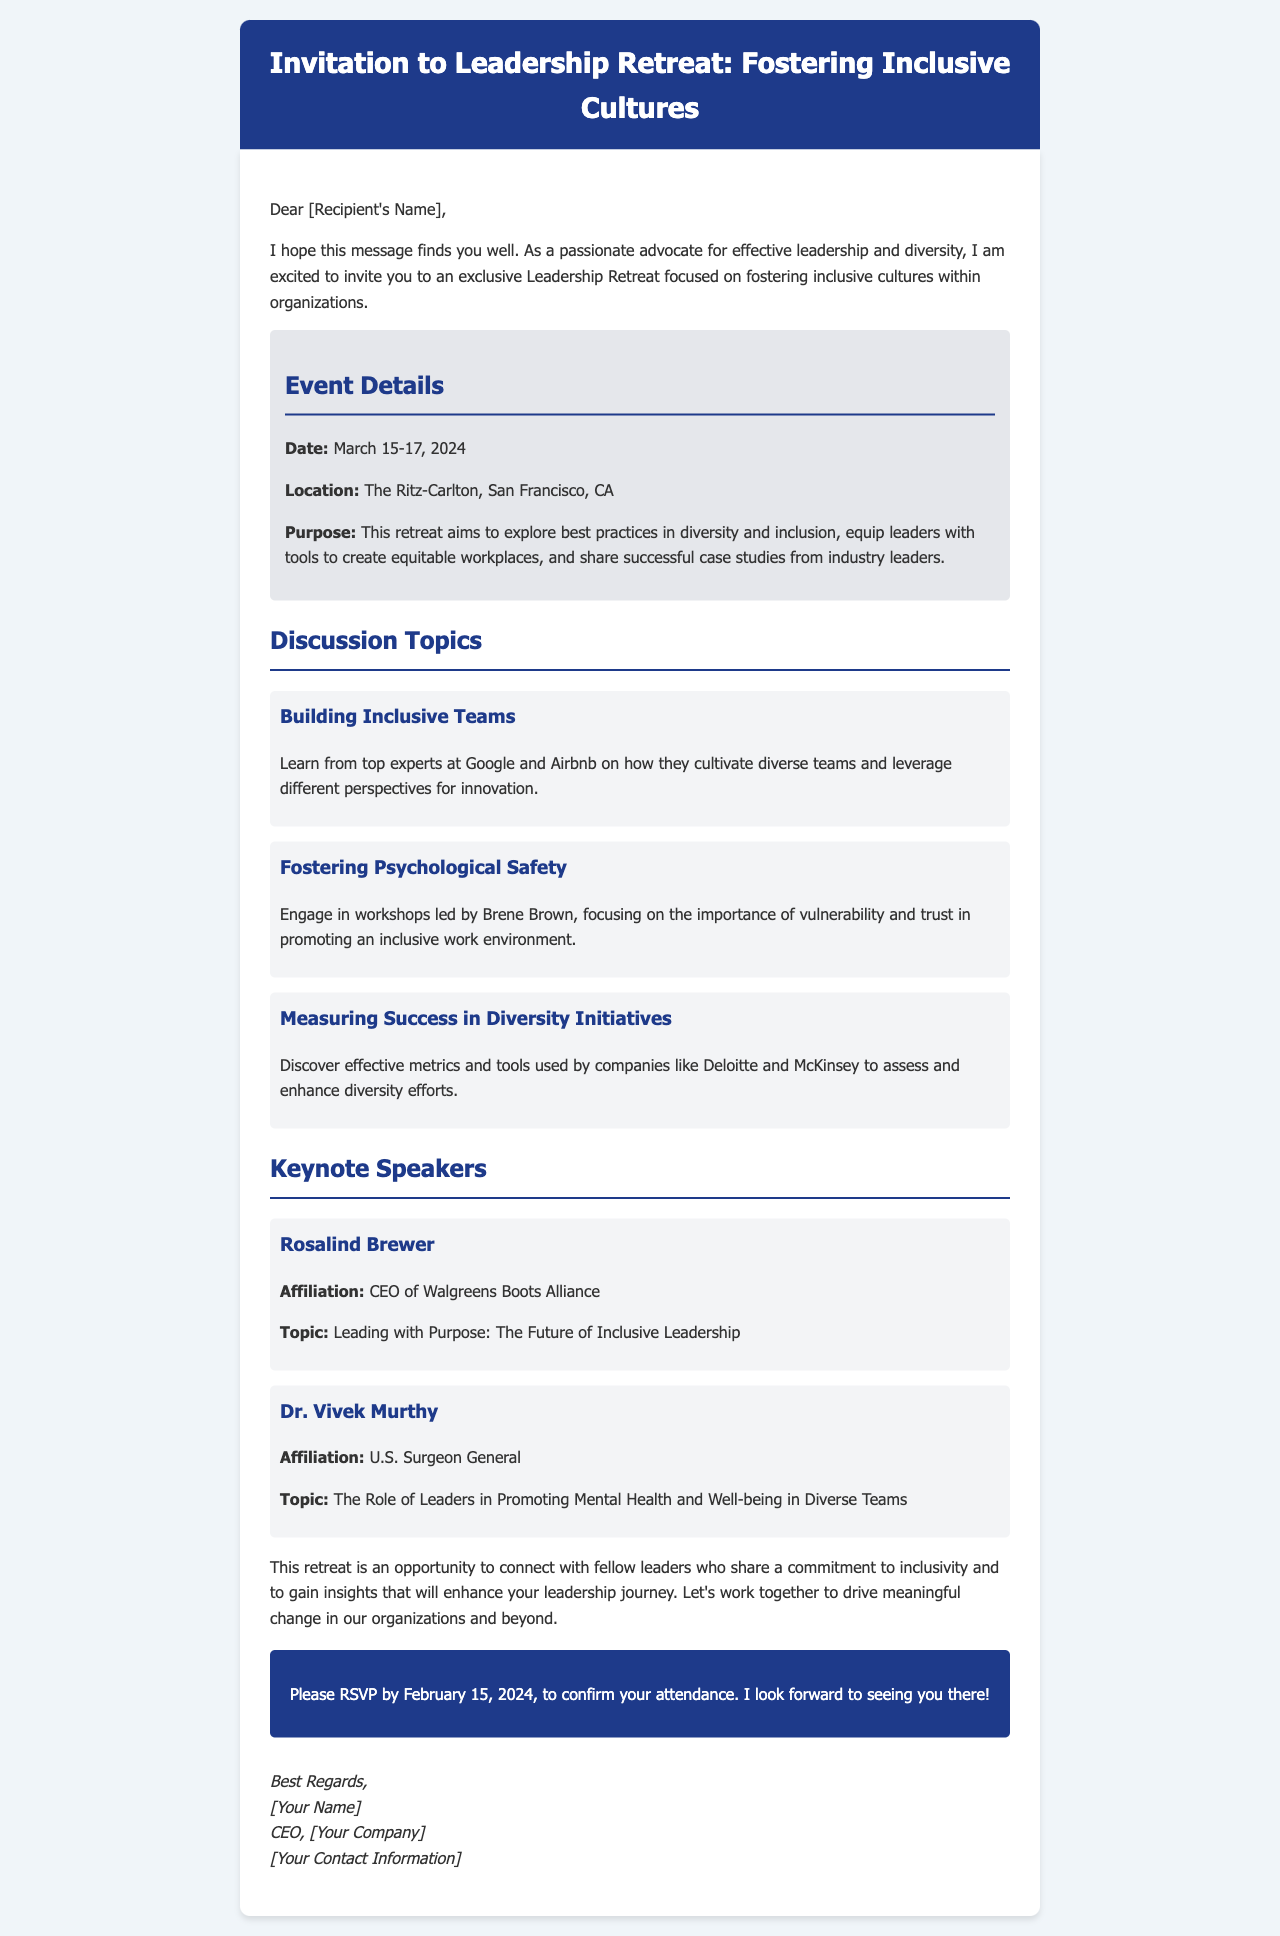What are the dates of the retreat? The document clearly states the dates for the retreat which are March 15-17, 2024.
Answer: March 15-17, 2024 Where is the retreat taking place? The document mentions that the location of the retreat is The Ritz-Carlton, San Francisco, CA.
Answer: The Ritz-Carlton, San Francisco, CA What is the purpose of the retreat? The purpose of the retreat is outlined in the event details, focusing on diversity and inclusion best practices and tools for leaders.
Answer: To explore best practices in diversity and inclusion Who is one of the keynote speakers? The document lists Rosalind Brewer as one of the keynote speakers and her affiliation.
Answer: Rosalind Brewer What is a topic discussed at the retreat? The document provides several discussion topics, one of which is "Building Inclusive Teams."
Answer: Building Inclusive Teams By when should attendees RSVP? The document specifies the RSVP deadline for attendees as February 15, 2024.
Answer: February 15, 2024 What is the affiliation of Dr. Vivek Murthy? The document identifies Dr. Vivek Murthy as the U.S. Surgeon General.
Answer: U.S. Surgeon General What is one of the companies mentioned in the diversity initiatives discussion? The document indicates that companies like Deloitte and McKinsey are discussed regarding diversity initiatives.
Answer: Deloitte and McKinsey 